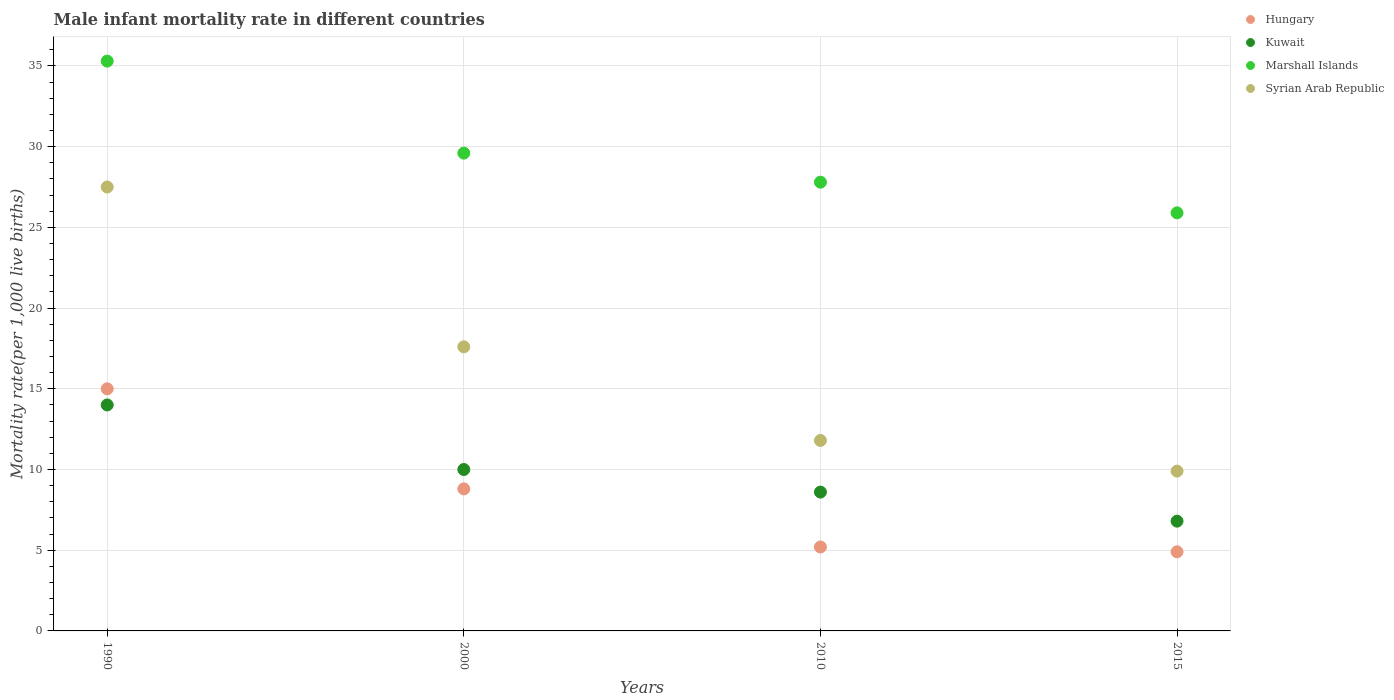What is the male infant mortality rate in Kuwait in 2000?
Give a very brief answer. 10. Across all years, what is the minimum male infant mortality rate in Kuwait?
Provide a succinct answer. 6.8. In which year was the male infant mortality rate in Marshall Islands minimum?
Make the answer very short. 2015. What is the total male infant mortality rate in Syrian Arab Republic in the graph?
Offer a very short reply. 66.8. What is the difference between the male infant mortality rate in Kuwait in 2000 and that in 2010?
Your response must be concise. 1.4. What is the difference between the male infant mortality rate in Hungary in 2000 and the male infant mortality rate in Marshall Islands in 1990?
Ensure brevity in your answer.  -26.5. What is the average male infant mortality rate in Kuwait per year?
Your response must be concise. 9.85. In the year 2015, what is the difference between the male infant mortality rate in Kuwait and male infant mortality rate in Syrian Arab Republic?
Ensure brevity in your answer.  -3.1. In how many years, is the male infant mortality rate in Hungary greater than 24?
Provide a short and direct response. 0. What is the ratio of the male infant mortality rate in Kuwait in 1990 to that in 2010?
Ensure brevity in your answer.  1.63. What is the difference between the highest and the second highest male infant mortality rate in Hungary?
Ensure brevity in your answer.  6.2. What is the difference between the highest and the lowest male infant mortality rate in Marshall Islands?
Keep it short and to the point. 9.4. In how many years, is the male infant mortality rate in Kuwait greater than the average male infant mortality rate in Kuwait taken over all years?
Make the answer very short. 2. Is the sum of the male infant mortality rate in Hungary in 2000 and 2015 greater than the maximum male infant mortality rate in Kuwait across all years?
Your answer should be very brief. No. Is it the case that in every year, the sum of the male infant mortality rate in Kuwait and male infant mortality rate in Marshall Islands  is greater than the sum of male infant mortality rate in Hungary and male infant mortality rate in Syrian Arab Republic?
Make the answer very short. Yes. Is it the case that in every year, the sum of the male infant mortality rate in Kuwait and male infant mortality rate in Hungary  is greater than the male infant mortality rate in Marshall Islands?
Offer a very short reply. No. Does the male infant mortality rate in Kuwait monotonically increase over the years?
Offer a very short reply. No. How many dotlines are there?
Ensure brevity in your answer.  4. How many years are there in the graph?
Make the answer very short. 4. Are the values on the major ticks of Y-axis written in scientific E-notation?
Provide a succinct answer. No. Does the graph contain any zero values?
Make the answer very short. No. Does the graph contain grids?
Provide a short and direct response. Yes. Where does the legend appear in the graph?
Your answer should be very brief. Top right. How many legend labels are there?
Your answer should be very brief. 4. What is the title of the graph?
Give a very brief answer. Male infant mortality rate in different countries. What is the label or title of the X-axis?
Your answer should be compact. Years. What is the label or title of the Y-axis?
Your response must be concise. Mortality rate(per 1,0 live births). What is the Mortality rate(per 1,000 live births) in Hungary in 1990?
Keep it short and to the point. 15. What is the Mortality rate(per 1,000 live births) in Marshall Islands in 1990?
Your answer should be very brief. 35.3. What is the Mortality rate(per 1,000 live births) of Marshall Islands in 2000?
Offer a very short reply. 29.6. What is the Mortality rate(per 1,000 live births) of Syrian Arab Republic in 2000?
Provide a succinct answer. 17.6. What is the Mortality rate(per 1,000 live births) in Marshall Islands in 2010?
Provide a succinct answer. 27.8. What is the Mortality rate(per 1,000 live births) of Hungary in 2015?
Your answer should be compact. 4.9. What is the Mortality rate(per 1,000 live births) of Marshall Islands in 2015?
Your answer should be compact. 25.9. What is the Mortality rate(per 1,000 live births) of Syrian Arab Republic in 2015?
Keep it short and to the point. 9.9. Across all years, what is the maximum Mortality rate(per 1,000 live births) of Hungary?
Give a very brief answer. 15. Across all years, what is the maximum Mortality rate(per 1,000 live births) of Marshall Islands?
Offer a terse response. 35.3. Across all years, what is the maximum Mortality rate(per 1,000 live births) in Syrian Arab Republic?
Make the answer very short. 27.5. Across all years, what is the minimum Mortality rate(per 1,000 live births) of Kuwait?
Give a very brief answer. 6.8. Across all years, what is the minimum Mortality rate(per 1,000 live births) in Marshall Islands?
Your response must be concise. 25.9. Across all years, what is the minimum Mortality rate(per 1,000 live births) of Syrian Arab Republic?
Offer a very short reply. 9.9. What is the total Mortality rate(per 1,000 live births) in Hungary in the graph?
Provide a short and direct response. 33.9. What is the total Mortality rate(per 1,000 live births) of Kuwait in the graph?
Provide a succinct answer. 39.4. What is the total Mortality rate(per 1,000 live births) of Marshall Islands in the graph?
Your response must be concise. 118.6. What is the total Mortality rate(per 1,000 live births) of Syrian Arab Republic in the graph?
Offer a very short reply. 66.8. What is the difference between the Mortality rate(per 1,000 live births) of Kuwait in 1990 and that in 2010?
Offer a terse response. 5.4. What is the difference between the Mortality rate(per 1,000 live births) in Marshall Islands in 1990 and that in 2010?
Give a very brief answer. 7.5. What is the difference between the Mortality rate(per 1,000 live births) in Hungary in 1990 and that in 2015?
Give a very brief answer. 10.1. What is the difference between the Mortality rate(per 1,000 live births) in Kuwait in 1990 and that in 2015?
Make the answer very short. 7.2. What is the difference between the Mortality rate(per 1,000 live births) of Syrian Arab Republic in 1990 and that in 2015?
Provide a short and direct response. 17.6. What is the difference between the Mortality rate(per 1,000 live births) of Kuwait in 2000 and that in 2010?
Offer a very short reply. 1.4. What is the difference between the Mortality rate(per 1,000 live births) of Marshall Islands in 2000 and that in 2010?
Ensure brevity in your answer.  1.8. What is the difference between the Mortality rate(per 1,000 live births) of Kuwait in 2000 and that in 2015?
Ensure brevity in your answer.  3.2. What is the difference between the Mortality rate(per 1,000 live births) in Syrian Arab Republic in 2000 and that in 2015?
Offer a terse response. 7.7. What is the difference between the Mortality rate(per 1,000 live births) of Hungary in 2010 and that in 2015?
Keep it short and to the point. 0.3. What is the difference between the Mortality rate(per 1,000 live births) in Kuwait in 2010 and that in 2015?
Provide a succinct answer. 1.8. What is the difference between the Mortality rate(per 1,000 live births) of Hungary in 1990 and the Mortality rate(per 1,000 live births) of Marshall Islands in 2000?
Your response must be concise. -14.6. What is the difference between the Mortality rate(per 1,000 live births) in Hungary in 1990 and the Mortality rate(per 1,000 live births) in Syrian Arab Republic in 2000?
Your answer should be very brief. -2.6. What is the difference between the Mortality rate(per 1,000 live births) of Kuwait in 1990 and the Mortality rate(per 1,000 live births) of Marshall Islands in 2000?
Offer a very short reply. -15.6. What is the difference between the Mortality rate(per 1,000 live births) in Hungary in 1990 and the Mortality rate(per 1,000 live births) in Marshall Islands in 2010?
Give a very brief answer. -12.8. What is the difference between the Mortality rate(per 1,000 live births) in Hungary in 1990 and the Mortality rate(per 1,000 live births) in Syrian Arab Republic in 2010?
Ensure brevity in your answer.  3.2. What is the difference between the Mortality rate(per 1,000 live births) of Kuwait in 1990 and the Mortality rate(per 1,000 live births) of Syrian Arab Republic in 2010?
Make the answer very short. 2.2. What is the difference between the Mortality rate(per 1,000 live births) in Marshall Islands in 1990 and the Mortality rate(per 1,000 live births) in Syrian Arab Republic in 2010?
Ensure brevity in your answer.  23.5. What is the difference between the Mortality rate(per 1,000 live births) of Hungary in 1990 and the Mortality rate(per 1,000 live births) of Kuwait in 2015?
Make the answer very short. 8.2. What is the difference between the Mortality rate(per 1,000 live births) of Hungary in 1990 and the Mortality rate(per 1,000 live births) of Syrian Arab Republic in 2015?
Provide a succinct answer. 5.1. What is the difference between the Mortality rate(per 1,000 live births) in Kuwait in 1990 and the Mortality rate(per 1,000 live births) in Marshall Islands in 2015?
Provide a succinct answer. -11.9. What is the difference between the Mortality rate(per 1,000 live births) of Marshall Islands in 1990 and the Mortality rate(per 1,000 live births) of Syrian Arab Republic in 2015?
Your response must be concise. 25.4. What is the difference between the Mortality rate(per 1,000 live births) of Hungary in 2000 and the Mortality rate(per 1,000 live births) of Syrian Arab Republic in 2010?
Offer a very short reply. -3. What is the difference between the Mortality rate(per 1,000 live births) of Kuwait in 2000 and the Mortality rate(per 1,000 live births) of Marshall Islands in 2010?
Offer a very short reply. -17.8. What is the difference between the Mortality rate(per 1,000 live births) in Marshall Islands in 2000 and the Mortality rate(per 1,000 live births) in Syrian Arab Republic in 2010?
Keep it short and to the point. 17.8. What is the difference between the Mortality rate(per 1,000 live births) of Hungary in 2000 and the Mortality rate(per 1,000 live births) of Marshall Islands in 2015?
Your answer should be very brief. -17.1. What is the difference between the Mortality rate(per 1,000 live births) of Hungary in 2000 and the Mortality rate(per 1,000 live births) of Syrian Arab Republic in 2015?
Ensure brevity in your answer.  -1.1. What is the difference between the Mortality rate(per 1,000 live births) of Kuwait in 2000 and the Mortality rate(per 1,000 live births) of Marshall Islands in 2015?
Keep it short and to the point. -15.9. What is the difference between the Mortality rate(per 1,000 live births) in Kuwait in 2000 and the Mortality rate(per 1,000 live births) in Syrian Arab Republic in 2015?
Offer a very short reply. 0.1. What is the difference between the Mortality rate(per 1,000 live births) in Hungary in 2010 and the Mortality rate(per 1,000 live births) in Marshall Islands in 2015?
Offer a very short reply. -20.7. What is the difference between the Mortality rate(per 1,000 live births) of Kuwait in 2010 and the Mortality rate(per 1,000 live births) of Marshall Islands in 2015?
Offer a very short reply. -17.3. What is the difference between the Mortality rate(per 1,000 live births) in Kuwait in 2010 and the Mortality rate(per 1,000 live births) in Syrian Arab Republic in 2015?
Make the answer very short. -1.3. What is the average Mortality rate(per 1,000 live births) in Hungary per year?
Provide a succinct answer. 8.47. What is the average Mortality rate(per 1,000 live births) of Kuwait per year?
Provide a short and direct response. 9.85. What is the average Mortality rate(per 1,000 live births) of Marshall Islands per year?
Offer a terse response. 29.65. What is the average Mortality rate(per 1,000 live births) of Syrian Arab Republic per year?
Ensure brevity in your answer.  16.7. In the year 1990, what is the difference between the Mortality rate(per 1,000 live births) in Hungary and Mortality rate(per 1,000 live births) in Kuwait?
Your response must be concise. 1. In the year 1990, what is the difference between the Mortality rate(per 1,000 live births) in Hungary and Mortality rate(per 1,000 live births) in Marshall Islands?
Provide a succinct answer. -20.3. In the year 1990, what is the difference between the Mortality rate(per 1,000 live births) of Hungary and Mortality rate(per 1,000 live births) of Syrian Arab Republic?
Your answer should be very brief. -12.5. In the year 1990, what is the difference between the Mortality rate(per 1,000 live births) in Kuwait and Mortality rate(per 1,000 live births) in Marshall Islands?
Provide a succinct answer. -21.3. In the year 1990, what is the difference between the Mortality rate(per 1,000 live births) in Kuwait and Mortality rate(per 1,000 live births) in Syrian Arab Republic?
Provide a short and direct response. -13.5. In the year 1990, what is the difference between the Mortality rate(per 1,000 live births) of Marshall Islands and Mortality rate(per 1,000 live births) of Syrian Arab Republic?
Ensure brevity in your answer.  7.8. In the year 2000, what is the difference between the Mortality rate(per 1,000 live births) in Hungary and Mortality rate(per 1,000 live births) in Marshall Islands?
Make the answer very short. -20.8. In the year 2000, what is the difference between the Mortality rate(per 1,000 live births) of Kuwait and Mortality rate(per 1,000 live births) of Marshall Islands?
Keep it short and to the point. -19.6. In the year 2000, what is the difference between the Mortality rate(per 1,000 live births) in Marshall Islands and Mortality rate(per 1,000 live births) in Syrian Arab Republic?
Provide a short and direct response. 12. In the year 2010, what is the difference between the Mortality rate(per 1,000 live births) of Hungary and Mortality rate(per 1,000 live births) of Marshall Islands?
Offer a very short reply. -22.6. In the year 2010, what is the difference between the Mortality rate(per 1,000 live births) in Kuwait and Mortality rate(per 1,000 live births) in Marshall Islands?
Keep it short and to the point. -19.2. In the year 2010, what is the difference between the Mortality rate(per 1,000 live births) of Marshall Islands and Mortality rate(per 1,000 live births) of Syrian Arab Republic?
Your answer should be compact. 16. In the year 2015, what is the difference between the Mortality rate(per 1,000 live births) of Hungary and Mortality rate(per 1,000 live births) of Kuwait?
Make the answer very short. -1.9. In the year 2015, what is the difference between the Mortality rate(per 1,000 live births) of Hungary and Mortality rate(per 1,000 live births) of Marshall Islands?
Keep it short and to the point. -21. In the year 2015, what is the difference between the Mortality rate(per 1,000 live births) in Hungary and Mortality rate(per 1,000 live births) in Syrian Arab Republic?
Offer a very short reply. -5. In the year 2015, what is the difference between the Mortality rate(per 1,000 live births) of Kuwait and Mortality rate(per 1,000 live births) of Marshall Islands?
Your answer should be compact. -19.1. In the year 2015, what is the difference between the Mortality rate(per 1,000 live births) in Kuwait and Mortality rate(per 1,000 live births) in Syrian Arab Republic?
Ensure brevity in your answer.  -3.1. What is the ratio of the Mortality rate(per 1,000 live births) of Hungary in 1990 to that in 2000?
Provide a short and direct response. 1.7. What is the ratio of the Mortality rate(per 1,000 live births) in Kuwait in 1990 to that in 2000?
Ensure brevity in your answer.  1.4. What is the ratio of the Mortality rate(per 1,000 live births) in Marshall Islands in 1990 to that in 2000?
Provide a short and direct response. 1.19. What is the ratio of the Mortality rate(per 1,000 live births) in Syrian Arab Republic in 1990 to that in 2000?
Keep it short and to the point. 1.56. What is the ratio of the Mortality rate(per 1,000 live births) of Hungary in 1990 to that in 2010?
Provide a short and direct response. 2.88. What is the ratio of the Mortality rate(per 1,000 live births) of Kuwait in 1990 to that in 2010?
Your response must be concise. 1.63. What is the ratio of the Mortality rate(per 1,000 live births) of Marshall Islands in 1990 to that in 2010?
Make the answer very short. 1.27. What is the ratio of the Mortality rate(per 1,000 live births) in Syrian Arab Republic in 1990 to that in 2010?
Give a very brief answer. 2.33. What is the ratio of the Mortality rate(per 1,000 live births) in Hungary in 1990 to that in 2015?
Keep it short and to the point. 3.06. What is the ratio of the Mortality rate(per 1,000 live births) in Kuwait in 1990 to that in 2015?
Keep it short and to the point. 2.06. What is the ratio of the Mortality rate(per 1,000 live births) in Marshall Islands in 1990 to that in 2015?
Ensure brevity in your answer.  1.36. What is the ratio of the Mortality rate(per 1,000 live births) in Syrian Arab Republic in 1990 to that in 2015?
Make the answer very short. 2.78. What is the ratio of the Mortality rate(per 1,000 live births) in Hungary in 2000 to that in 2010?
Your response must be concise. 1.69. What is the ratio of the Mortality rate(per 1,000 live births) in Kuwait in 2000 to that in 2010?
Your answer should be very brief. 1.16. What is the ratio of the Mortality rate(per 1,000 live births) in Marshall Islands in 2000 to that in 2010?
Give a very brief answer. 1.06. What is the ratio of the Mortality rate(per 1,000 live births) in Syrian Arab Republic in 2000 to that in 2010?
Offer a terse response. 1.49. What is the ratio of the Mortality rate(per 1,000 live births) in Hungary in 2000 to that in 2015?
Ensure brevity in your answer.  1.8. What is the ratio of the Mortality rate(per 1,000 live births) in Kuwait in 2000 to that in 2015?
Provide a short and direct response. 1.47. What is the ratio of the Mortality rate(per 1,000 live births) in Marshall Islands in 2000 to that in 2015?
Provide a succinct answer. 1.14. What is the ratio of the Mortality rate(per 1,000 live births) in Syrian Arab Republic in 2000 to that in 2015?
Make the answer very short. 1.78. What is the ratio of the Mortality rate(per 1,000 live births) in Hungary in 2010 to that in 2015?
Provide a short and direct response. 1.06. What is the ratio of the Mortality rate(per 1,000 live births) in Kuwait in 2010 to that in 2015?
Your response must be concise. 1.26. What is the ratio of the Mortality rate(per 1,000 live births) in Marshall Islands in 2010 to that in 2015?
Provide a short and direct response. 1.07. What is the ratio of the Mortality rate(per 1,000 live births) in Syrian Arab Republic in 2010 to that in 2015?
Keep it short and to the point. 1.19. What is the difference between the highest and the second highest Mortality rate(per 1,000 live births) in Kuwait?
Offer a very short reply. 4. What is the difference between the highest and the second highest Mortality rate(per 1,000 live births) of Marshall Islands?
Provide a succinct answer. 5.7. What is the difference between the highest and the second highest Mortality rate(per 1,000 live births) of Syrian Arab Republic?
Your answer should be compact. 9.9. What is the difference between the highest and the lowest Mortality rate(per 1,000 live births) of Marshall Islands?
Provide a short and direct response. 9.4. 